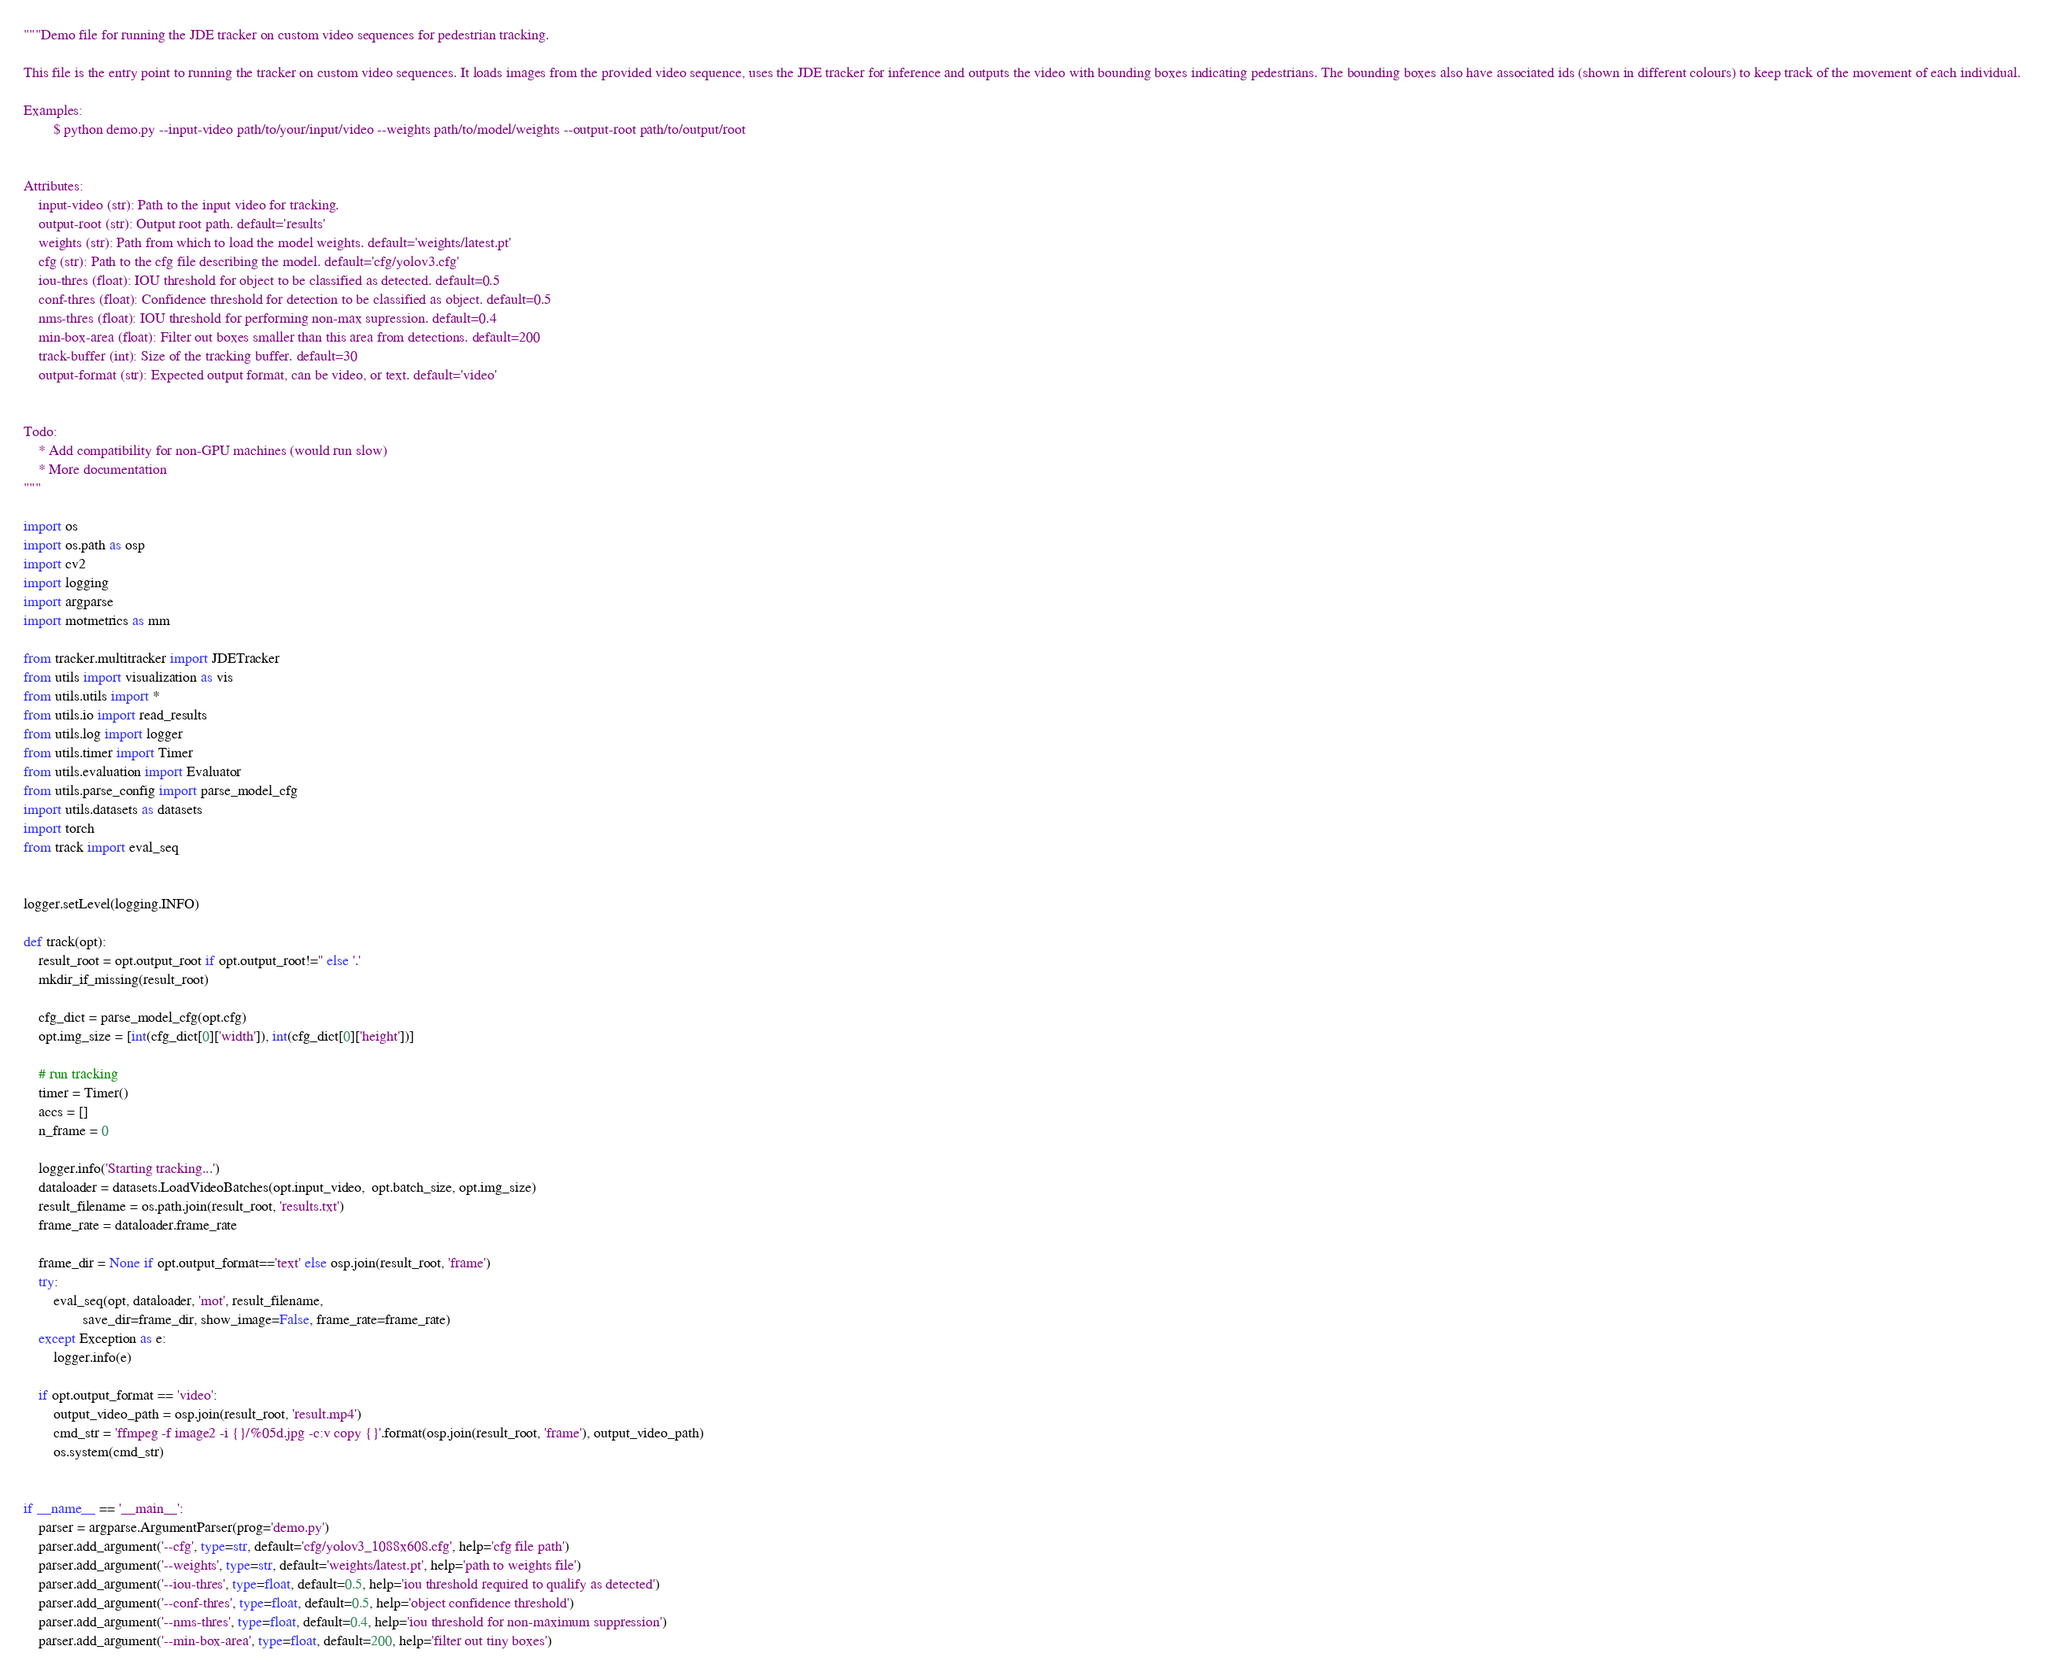Convert code to text. <code><loc_0><loc_0><loc_500><loc_500><_Python_>"""Demo file for running the JDE tracker on custom video sequences for pedestrian tracking. 

This file is the entry point to running the tracker on custom video sequences. It loads images from the provided video sequence, uses the JDE tracker for inference and outputs the video with bounding boxes indicating pedestrians. The bounding boxes also have associated ids (shown in different colours) to keep track of the movement of each individual. 

Examples:
        $ python demo.py --input-video path/to/your/input/video --weights path/to/model/weights --output-root path/to/output/root


Attributes:
    input-video (str): Path to the input video for tracking.
    output-root (str): Output root path. default='results'
    weights (str): Path from which to load the model weights. default='weights/latest.pt'
    cfg (str): Path to the cfg file describing the model. default='cfg/yolov3.cfg'
    iou-thres (float): IOU threshold for object to be classified as detected. default=0.5
    conf-thres (float): Confidence threshold for detection to be classified as object. default=0.5
    nms-thres (float): IOU threshold for performing non-max supression. default=0.4
    min-box-area (float): Filter out boxes smaller than this area from detections. default=200
    track-buffer (int): Size of the tracking buffer. default=30
    output-format (str): Expected output format, can be video, or text. default='video'
    

Todo:
    * Add compatibility for non-GPU machines (would run slow)
    * More documentation
"""

import os
import os.path as osp
import cv2
import logging
import argparse
import motmetrics as mm

from tracker.multitracker import JDETracker
from utils import visualization as vis
from utils.utils import *
from utils.io import read_results
from utils.log import logger
from utils.timer import Timer
from utils.evaluation import Evaluator
from utils.parse_config import parse_model_cfg
import utils.datasets as datasets
import torch
from track import eval_seq


logger.setLevel(logging.INFO)

def track(opt):    
    result_root = opt.output_root if opt.output_root!='' else '.'
    mkdir_if_missing(result_root)

    cfg_dict = parse_model_cfg(opt.cfg)
    opt.img_size = [int(cfg_dict[0]['width']), int(cfg_dict[0]['height'])]

    # run tracking
    timer = Timer()
    accs = []
    n_frame = 0

    logger.info('Starting tracking...')
    dataloader = datasets.LoadVideoBatches(opt.input_video,  opt.batch_size, opt.img_size)
    result_filename = os.path.join(result_root, 'results.txt')
    frame_rate = dataloader.frame_rate 

    frame_dir = None if opt.output_format=='text' else osp.join(result_root, 'frame')
    try:
        eval_seq(opt, dataloader, 'mot', result_filename,
                save_dir=frame_dir, show_image=False, frame_rate=frame_rate)
    except Exception as e:
        logger.info(e)

    if opt.output_format == 'video':
        output_video_path = osp.join(result_root, 'result.mp4')
        cmd_str = 'ffmpeg -f image2 -i {}/%05d.jpg -c:v copy {}'.format(osp.join(result_root, 'frame'), output_video_path)
        os.system(cmd_str)

        
if __name__ == '__main__':
    parser = argparse.ArgumentParser(prog='demo.py')
    parser.add_argument('--cfg', type=str, default='cfg/yolov3_1088x608.cfg', help='cfg file path')
    parser.add_argument('--weights', type=str, default='weights/latest.pt', help='path to weights file')
    parser.add_argument('--iou-thres', type=float, default=0.5, help='iou threshold required to qualify as detected')
    parser.add_argument('--conf-thres', type=float, default=0.5, help='object confidence threshold')
    parser.add_argument('--nms-thres', type=float, default=0.4, help='iou threshold for non-maximum suppression')
    parser.add_argument('--min-box-area', type=float, default=200, help='filter out tiny boxes')</code> 